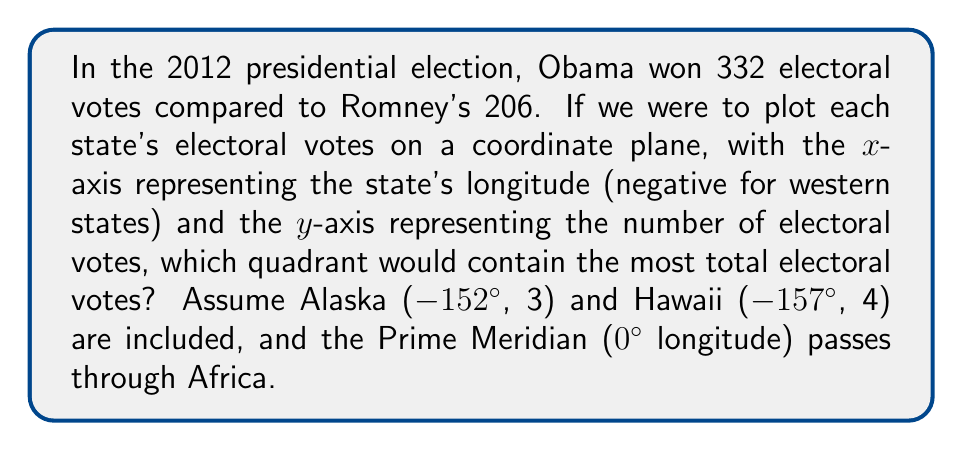Give your solution to this math problem. To solve this problem, we need to consider the distribution of electoral votes across the United States. Let's break it down step-by-step:

1) First, recall that the U.S. mainland spans from approximately -125° (West Coast) to -67° (East Coast) longitude.

2) All U.S. states have negative longitude values, so we're only dealing with the left half of the coordinate plane (Quadrants II and III).

3) Quadrant II represents states with negative longitude (left of y-axis) and positive electoral votes (above x-axis), which includes all states.

4) Quadrant III would represent states with negative longitude and negative electoral votes, which is impossible in this context.

5) Let's consider the distribution of electoral votes:
   - Large electoral vote states on the East Coast: New York (29), Florida (29), Pennsylvania (20)
   - Large electoral vote states in the Midwest: Illinois (20), Ohio (18)
   - Large electoral vote state on the West Coast: California (55)

6) While California has the most electoral votes, the concentration of populous states on the East Coast and in the Midwest means that the majority of electoral votes are closer to the y-axis (less negative longitude).

7) Alaska (-152°, 3) and Hawaii (-157°, 4), despite being far to the west, contribute only 7 electoral votes total.

Therefore, Quadrant II will contain all 538 electoral votes, as all states have negative longitude and positive electoral votes.
Answer: Quadrant II contains the most total electoral votes, with all 538 electoral votes plotted in this quadrant. 